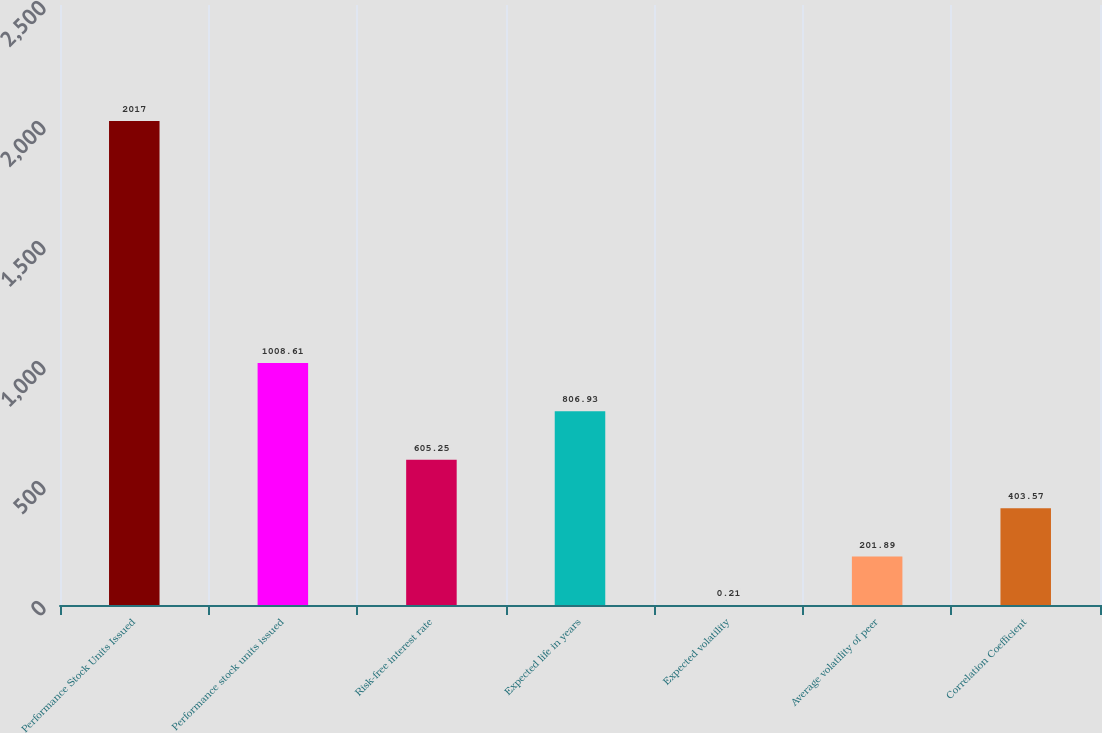<chart> <loc_0><loc_0><loc_500><loc_500><bar_chart><fcel>Performance Stock Units Issued<fcel>Performance stock units issued<fcel>Risk-free interest rate<fcel>Expected life in years<fcel>Expected volatility<fcel>Average volatility of peer<fcel>Correlation Coefficient<nl><fcel>2017<fcel>1008.61<fcel>605.25<fcel>806.93<fcel>0.21<fcel>201.89<fcel>403.57<nl></chart> 